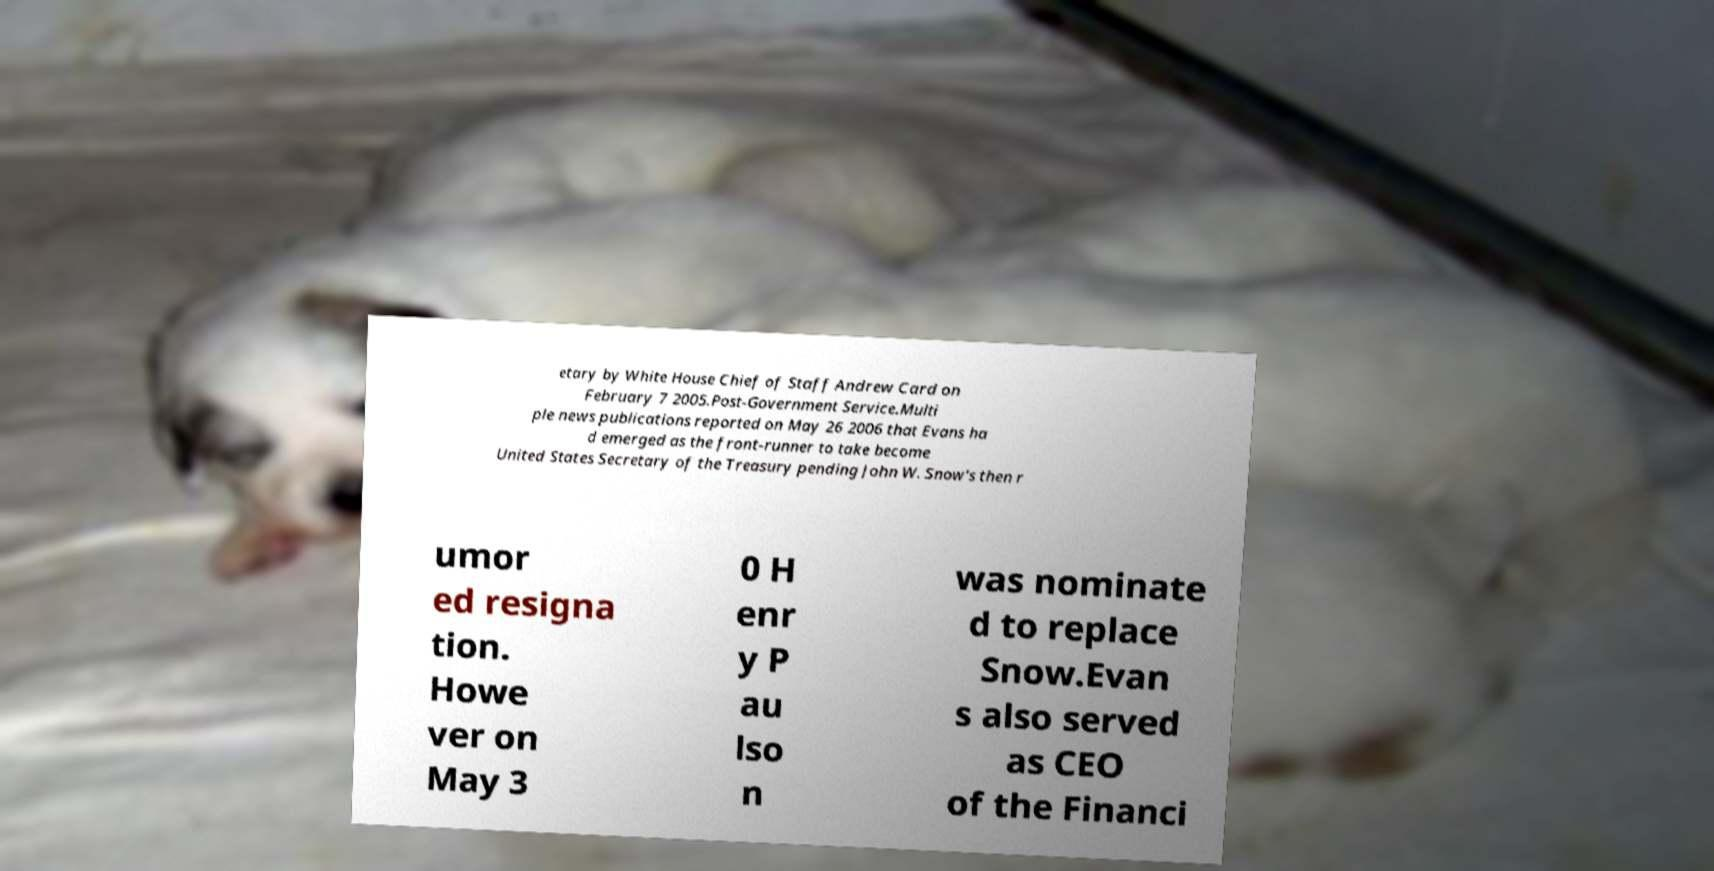Could you extract and type out the text from this image? etary by White House Chief of Staff Andrew Card on February 7 2005.Post-Government Service.Multi ple news publications reported on May 26 2006 that Evans ha d emerged as the front-runner to take become United States Secretary of the Treasury pending John W. Snow's then r umor ed resigna tion. Howe ver on May 3 0 H enr y P au lso n was nominate d to replace Snow.Evan s also served as CEO of the Financi 